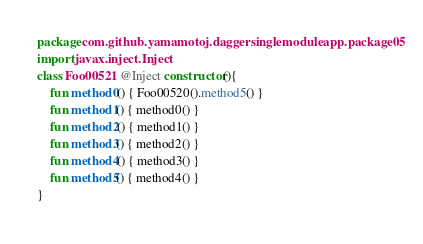Convert code to text. <code><loc_0><loc_0><loc_500><loc_500><_Kotlin_>package com.github.yamamotoj.daggersinglemoduleapp.package05
import javax.inject.Inject
class Foo00521 @Inject constructor(){
    fun method0() { Foo00520().method5() }
    fun method1() { method0() }
    fun method2() { method1() }
    fun method3() { method2() }
    fun method4() { method3() }
    fun method5() { method4() }
}
</code> 